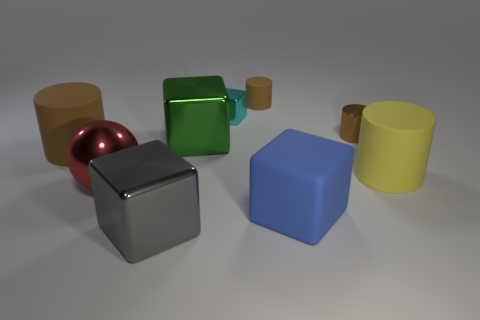What number of shiny things have the same color as the small matte cylinder?
Provide a succinct answer. 1. What number of large matte cylinders are left of the metallic block that is behind the metal cylinder?
Your answer should be very brief. 1. What is the size of the yellow cylinder that is made of the same material as the large blue thing?
Provide a short and direct response. Large. The cyan block is what size?
Make the answer very short. Small. Is the material of the green block the same as the big red object?
Ensure brevity in your answer.  Yes. What number of balls are either small brown matte things or green objects?
Keep it short and to the point. 0. There is a large matte thing that is on the left side of the thing behind the small cyan metal cube; what color is it?
Your answer should be compact. Brown. What is the size of the other rubber object that is the same color as the tiny rubber object?
Keep it short and to the point. Large. How many gray metal things are in front of the large cube that is behind the brown matte cylinder on the left side of the small metallic block?
Offer a very short reply. 1. There is a rubber object that is in front of the big yellow object; is it the same shape as the big metallic object behind the large shiny ball?
Your response must be concise. Yes. 